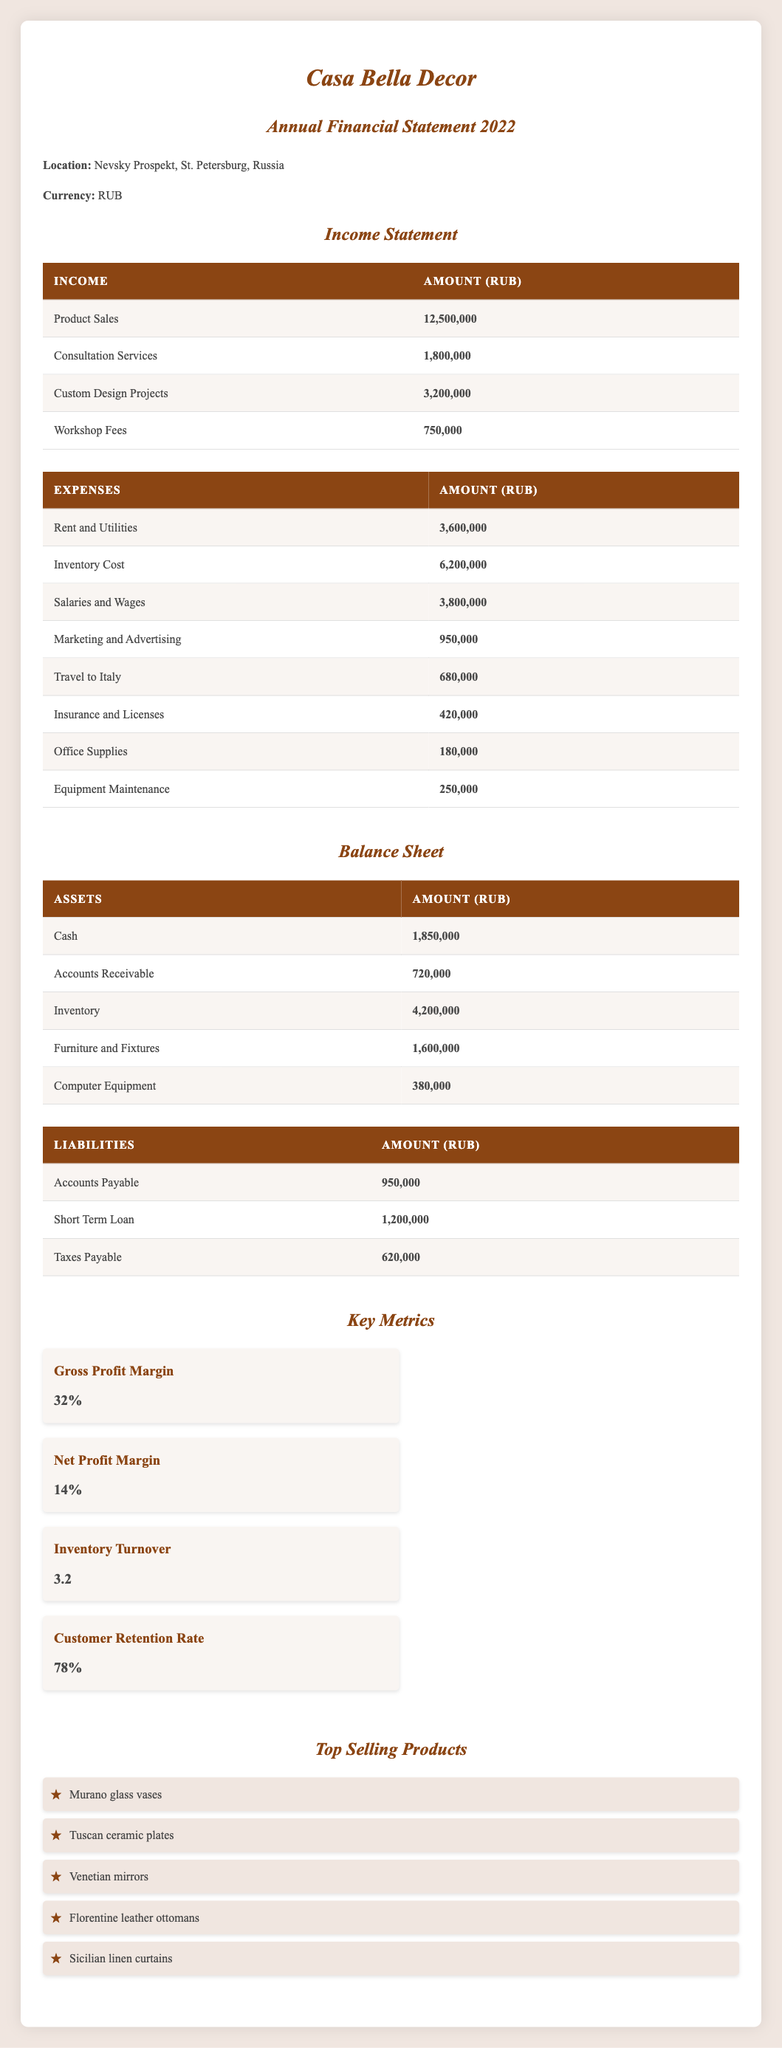What is the total income generated by Casa Bella Decor in 2022? To find the total income, we need to sum the amounts from all income sources: Product Sales (12,500,000) + Consultation Services (1,800,000) + Custom Design Projects (3,200,000) + Workshop Fees (750,000) = 18,250,000.
Answer: 18,250,000 What was the largest expense for Casa Bella Decor in 2022? From the expenses listed, the largest amount is the Inventory Cost, which is 6,200,000.
Answer: 6,200,000 Is Casa Bella Decor operating at a profit in 2022? To determine profitability, we compare total income (18,250,000) and total expenses (sum: Rent and Utilities 3,600,000 + Inventory Cost 6,200,000 + Salaries and Wages 3,800,000 + Marketing and Advertising 950,000 + Travel to Italy 680,000 + Insurance and Licenses 420,000 + Office Supplies 180,000 + Equipment Maintenance 250,000 = 17,080,000). Since income exceeds expenses, the answer is yes.
Answer: Yes Calculate the net profit for Casa Bella Decor in 2022. The net profit is calculated by subtracting total expenses from total income. Total income is 18,250,000 and total expenses are 17,080,000, so net profit = 18,250,000 - 17,080,000 = 1,170,000.
Answer: 1,170,000 What percentage of Casa Bella Decor's income comes from product sales? Product Sales amounting to 12,500,000 represent a proportion of total income (18,250,000). To find the percentage: (12,500,000 / 18,250,000) * 100 = 68.49%.
Answer: 68.49% 